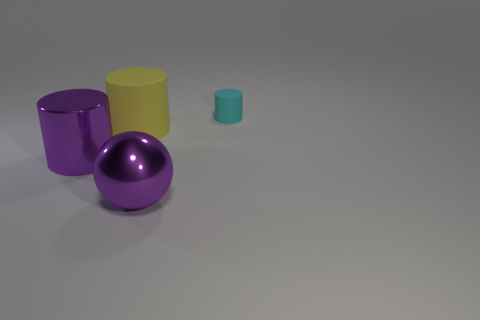Subtract all yellow cylinders. Subtract all red blocks. How many cylinders are left? 2 Add 1 big cylinders. How many objects exist? 5 Subtract all spheres. How many objects are left? 3 Add 2 large yellow rubber things. How many large yellow rubber things exist? 3 Subtract 0 green spheres. How many objects are left? 4 Subtract all large gray matte cylinders. Subtract all shiny balls. How many objects are left? 3 Add 4 large purple metal balls. How many large purple metal balls are left? 5 